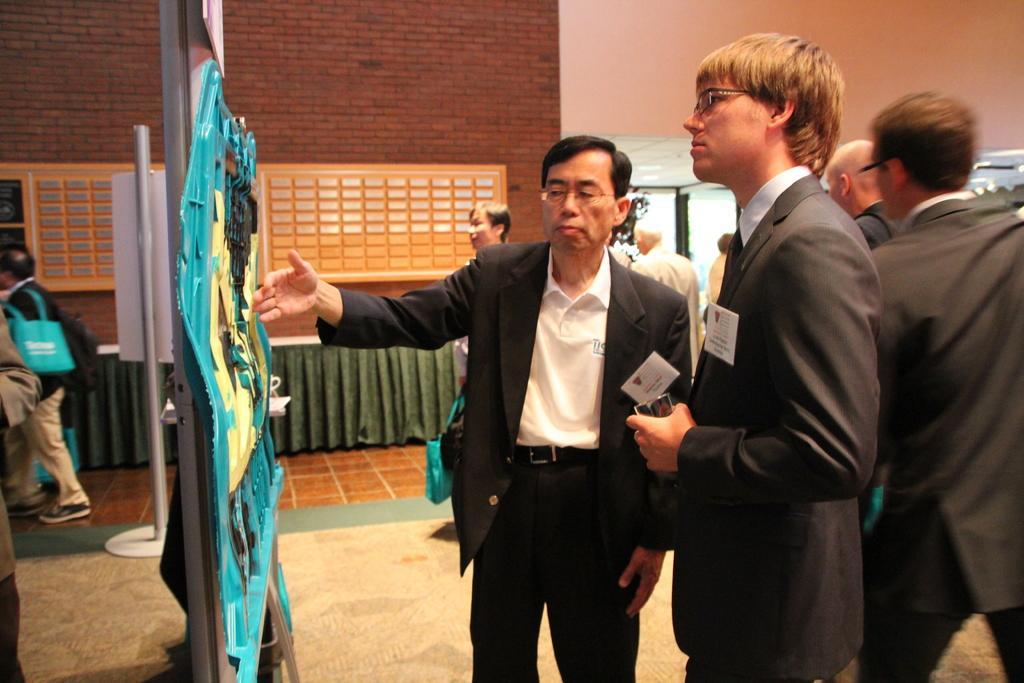Could you give a brief overview of what you see in this image? In the image there are two people in the foreground and on the left side there is some project and a person is explaining the project, around them there are many other people, in the background there is a brick wall and beside the wall there is a door. 